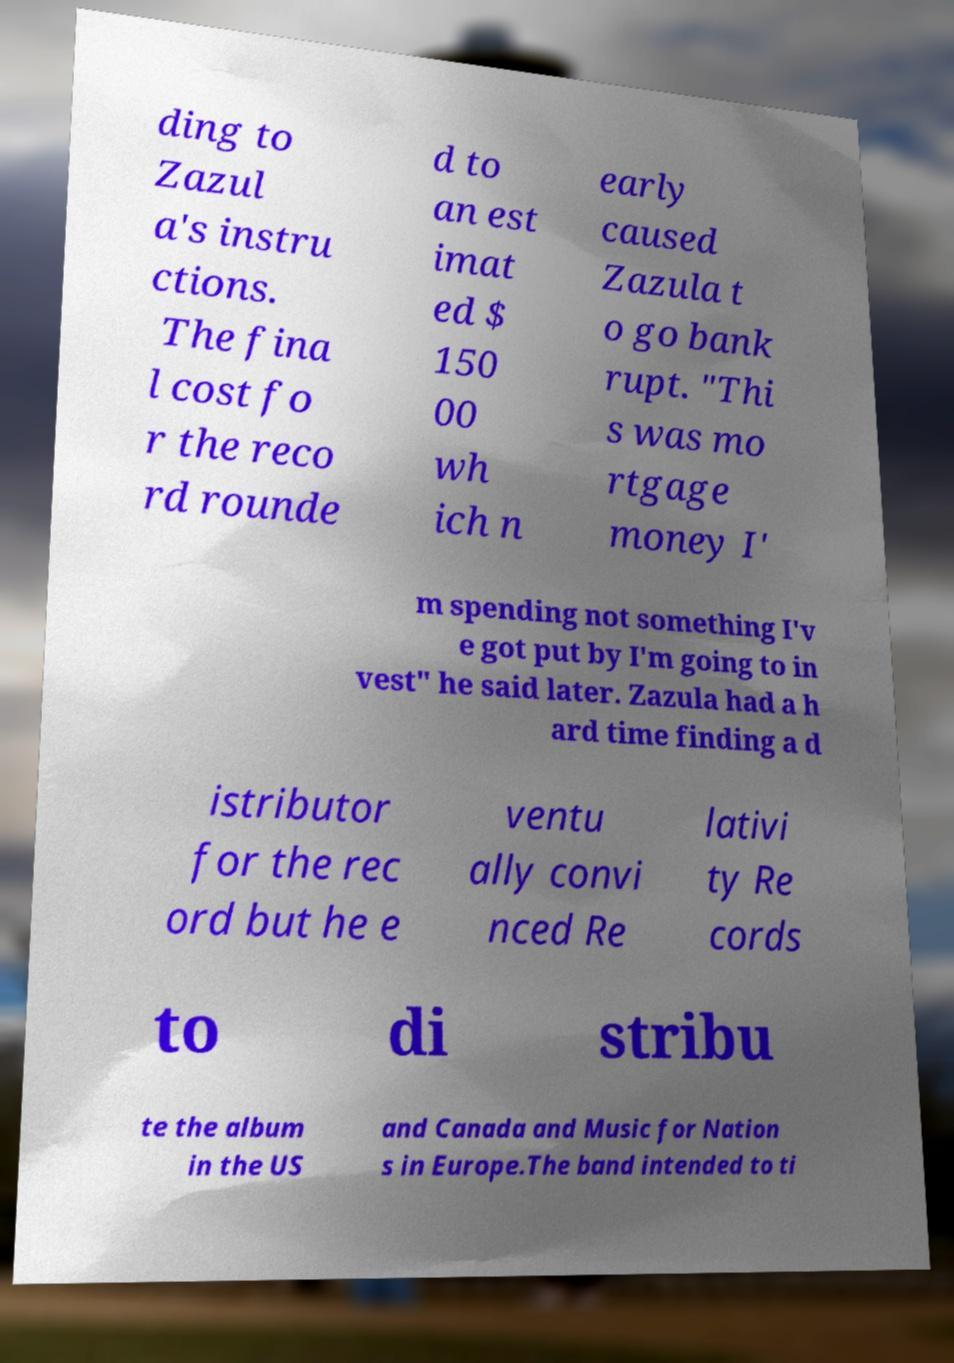There's text embedded in this image that I need extracted. Can you transcribe it verbatim? ding to Zazul a's instru ctions. The fina l cost fo r the reco rd rounde d to an est imat ed $ 150 00 wh ich n early caused Zazula t o go bank rupt. "Thi s was mo rtgage money I' m spending not something I'v e got put by I'm going to in vest" he said later. Zazula had a h ard time finding a d istributor for the rec ord but he e ventu ally convi nced Re lativi ty Re cords to di stribu te the album in the US and Canada and Music for Nation s in Europe.The band intended to ti 